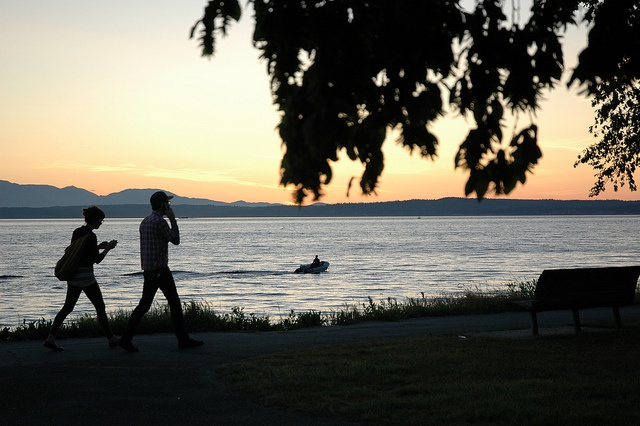Describe the objects in this image and their specific colors. I can see bench in lightgray, black, darkgray, and gray tones, people in lightgray, black, darkgray, gray, and blue tones, people in lightgray, black, gray, and darkgray tones, backpack in lightgray, black, gray, and darkgray tones, and handbag in black, gray, and lightgray tones in this image. 